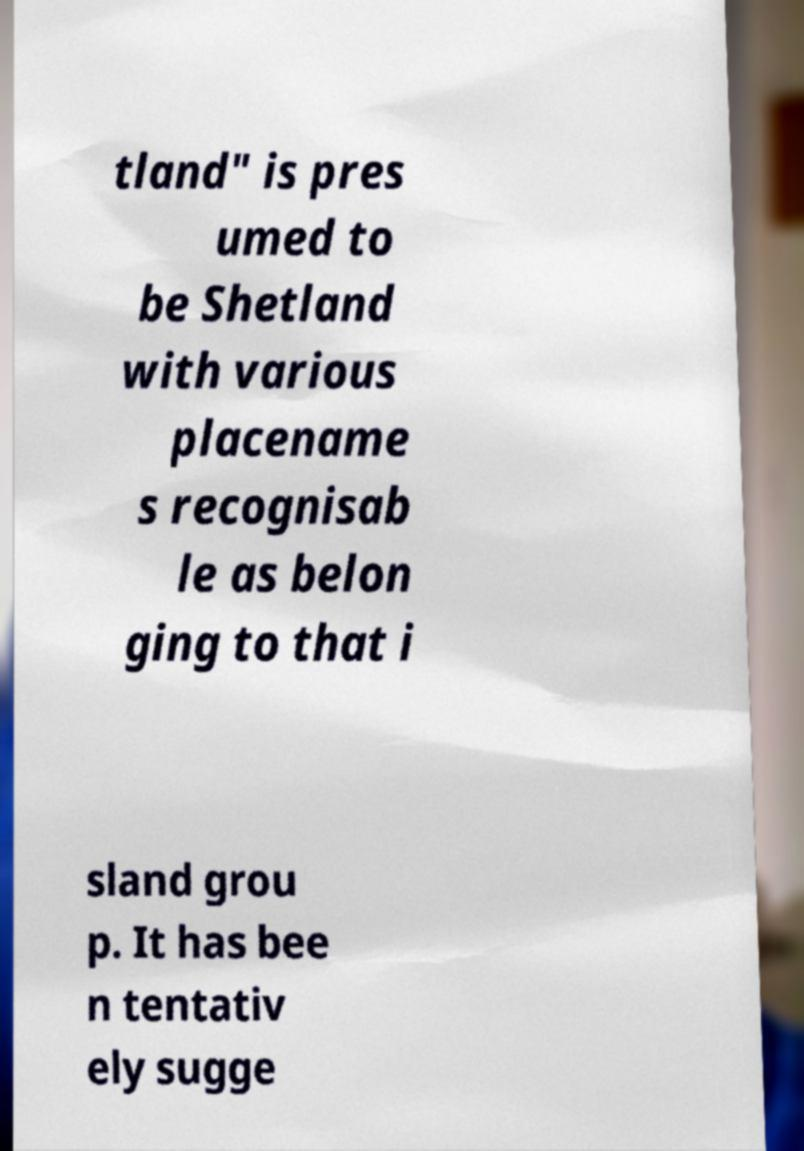Can you read and provide the text displayed in the image?This photo seems to have some interesting text. Can you extract and type it out for me? tland" is pres umed to be Shetland with various placename s recognisab le as belon ging to that i sland grou p. It has bee n tentativ ely sugge 